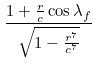Convert formula to latex. <formula><loc_0><loc_0><loc_500><loc_500>\frac { 1 + \frac { r } { c } \cos \lambda _ { f } } { \sqrt { 1 - \frac { r ^ { 7 } } { c ^ { 7 } } } }</formula> 